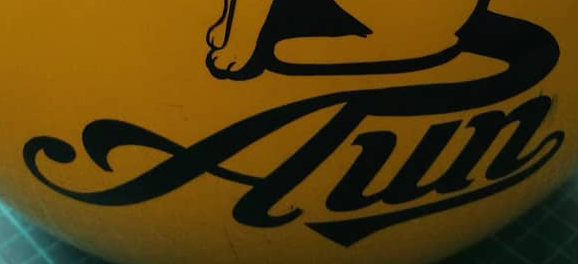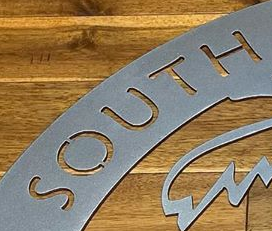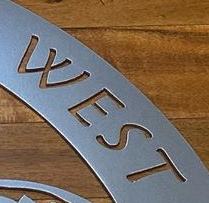Read the text from these images in sequence, separated by a semicolon. Aun; SOUTH; WEST 